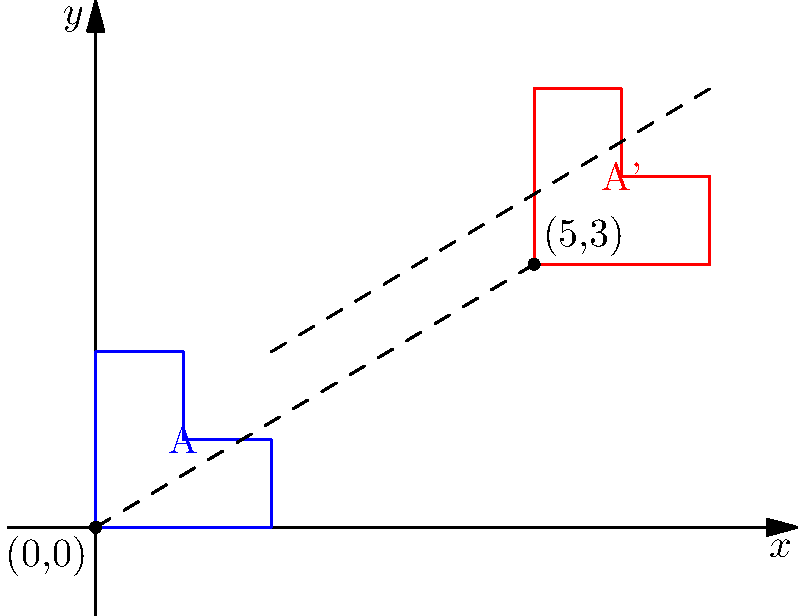In the coordinate plane above, shape A has been translated to create shape A'. What is the translation vector that maps shape A onto shape A'? Express your answer as an ordered pair. To find the translation vector, we need to determine how far the shape has moved horizontally (along the x-axis) and vertically (along the y-axis). Let's approach this step-by-step:

1) First, let's identify a corresponding point on both shapes. The bottom-left corner of shape A is at (0,0), and the bottom-left corner of shape A' is at (5,3).

2) To find the horizontal component of the translation:
   - x-coordinate of A': 5
   - x-coordinate of A: 0
   - Horizontal shift = 5 - 0 = 5 units to the right

3) To find the vertical component of the translation:
   - y-coordinate of A': 3
   - y-coordinate of A: 0
   - Vertical shift = 3 - 0 = 3 units up

4) The translation vector is represented by the horizontal and vertical shifts:
   $\langle 5, 3 \rangle$ or (5,3)

This vector indicates that every point of shape A has been moved 5 units to the right and 3 units up to create shape A'.
Answer: (5,3) 